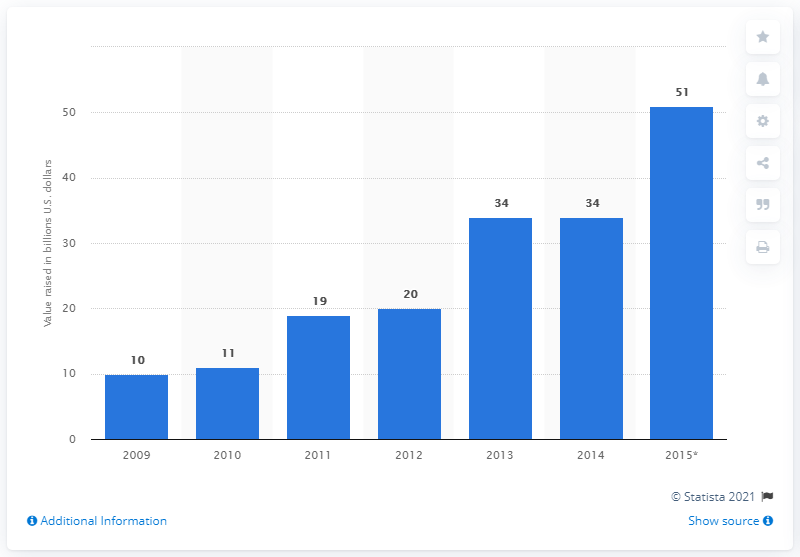Specify some key components in this picture. In 2015, a total of 51 million dollars were raised on the London Stock Exchange through sukuk issues. 